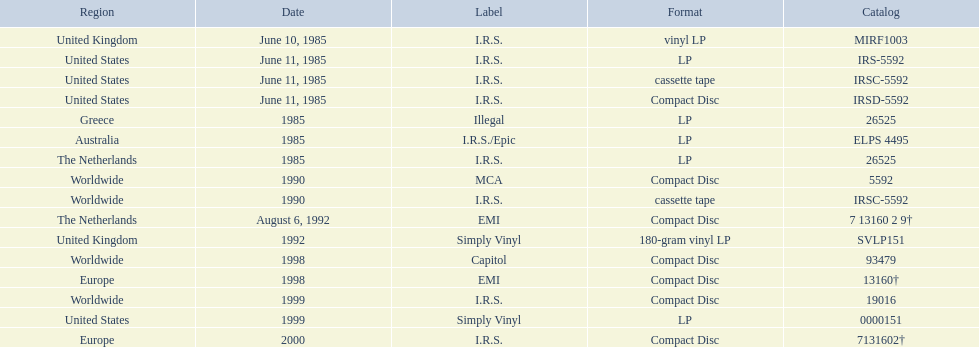In which region did the release occur last? Europe. 